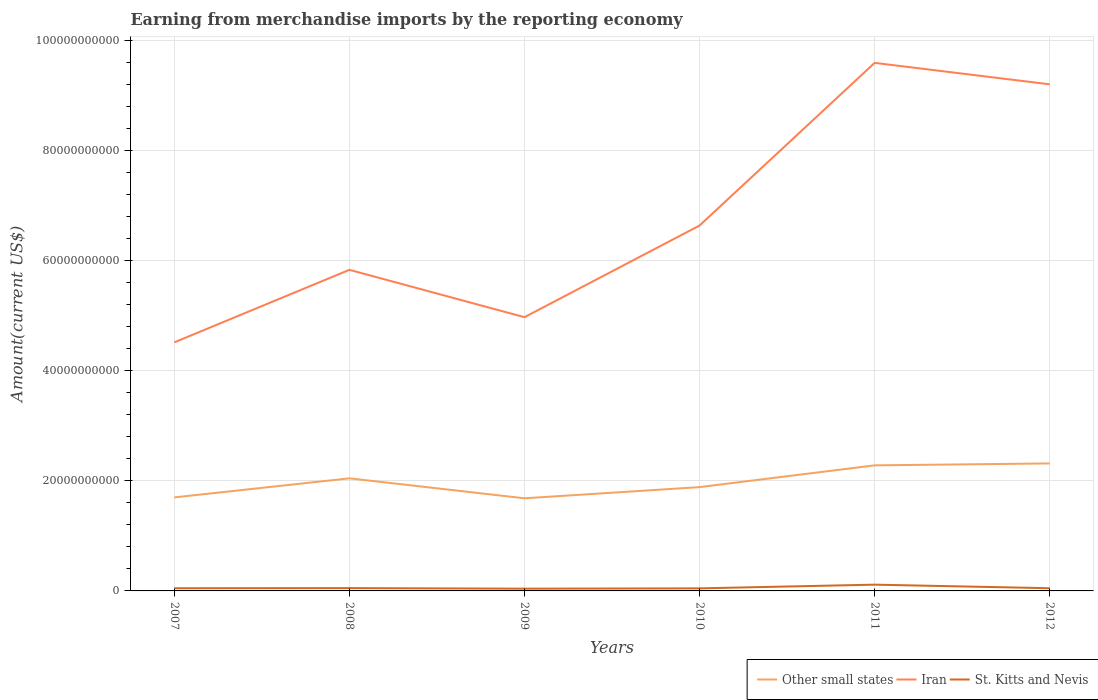How many different coloured lines are there?
Your response must be concise. 3. Is the number of lines equal to the number of legend labels?
Keep it short and to the point. Yes. Across all years, what is the maximum amount earned from merchandise imports in St. Kitts and Nevis?
Give a very brief answer. 4.09e+08. In which year was the amount earned from merchandise imports in St. Kitts and Nevis maximum?
Your answer should be very brief. 2009. What is the total amount earned from merchandise imports in St. Kitts and Nevis in the graph?
Offer a terse response. -2.48e+07. What is the difference between the highest and the second highest amount earned from merchandise imports in St. Kitts and Nevis?
Your answer should be very brief. 7.31e+08. How many lines are there?
Your response must be concise. 3. Are the values on the major ticks of Y-axis written in scientific E-notation?
Your answer should be very brief. No. Does the graph contain any zero values?
Provide a short and direct response. No. Does the graph contain grids?
Keep it short and to the point. Yes. How many legend labels are there?
Provide a succinct answer. 3. How are the legend labels stacked?
Provide a succinct answer. Horizontal. What is the title of the graph?
Provide a short and direct response. Earning from merchandise imports by the reporting economy. Does "Haiti" appear as one of the legend labels in the graph?
Offer a very short reply. No. What is the label or title of the X-axis?
Your answer should be very brief. Years. What is the label or title of the Y-axis?
Ensure brevity in your answer.  Amount(current US$). What is the Amount(current US$) of Other small states in 2007?
Offer a terse response. 1.70e+1. What is the Amount(current US$) in Iran in 2007?
Make the answer very short. 4.52e+1. What is the Amount(current US$) in St. Kitts and Nevis in 2007?
Ensure brevity in your answer.  4.88e+08. What is the Amount(current US$) of Other small states in 2008?
Provide a succinct answer. 2.05e+1. What is the Amount(current US$) in Iran in 2008?
Your response must be concise. 5.83e+1. What is the Amount(current US$) in St. Kitts and Nevis in 2008?
Your answer should be compact. 5.12e+08. What is the Amount(current US$) of Other small states in 2009?
Offer a terse response. 1.68e+1. What is the Amount(current US$) of Iran in 2009?
Offer a terse response. 4.97e+1. What is the Amount(current US$) of St. Kitts and Nevis in 2009?
Your answer should be very brief. 4.09e+08. What is the Amount(current US$) of Other small states in 2010?
Provide a succinct answer. 1.89e+1. What is the Amount(current US$) in Iran in 2010?
Make the answer very short. 6.64e+1. What is the Amount(current US$) in St. Kitts and Nevis in 2010?
Ensure brevity in your answer.  4.66e+08. What is the Amount(current US$) of Other small states in 2011?
Your answer should be very brief. 2.28e+1. What is the Amount(current US$) of Iran in 2011?
Make the answer very short. 9.59e+1. What is the Amount(current US$) in St. Kitts and Nevis in 2011?
Keep it short and to the point. 1.14e+09. What is the Amount(current US$) of Other small states in 2012?
Make the answer very short. 2.32e+1. What is the Amount(current US$) in Iran in 2012?
Ensure brevity in your answer.  9.21e+1. What is the Amount(current US$) of St. Kitts and Nevis in 2012?
Provide a succinct answer. 4.90e+08. Across all years, what is the maximum Amount(current US$) of Other small states?
Your answer should be compact. 2.32e+1. Across all years, what is the maximum Amount(current US$) of Iran?
Make the answer very short. 9.59e+1. Across all years, what is the maximum Amount(current US$) in St. Kitts and Nevis?
Your response must be concise. 1.14e+09. Across all years, what is the minimum Amount(current US$) of Other small states?
Your answer should be compact. 1.68e+1. Across all years, what is the minimum Amount(current US$) of Iran?
Your answer should be very brief. 4.52e+1. Across all years, what is the minimum Amount(current US$) in St. Kitts and Nevis?
Offer a terse response. 4.09e+08. What is the total Amount(current US$) of Other small states in the graph?
Your response must be concise. 1.19e+11. What is the total Amount(current US$) of Iran in the graph?
Give a very brief answer. 4.08e+11. What is the total Amount(current US$) in St. Kitts and Nevis in the graph?
Offer a very short reply. 3.50e+09. What is the difference between the Amount(current US$) in Other small states in 2007 and that in 2008?
Provide a short and direct response. -3.47e+09. What is the difference between the Amount(current US$) of Iran in 2007 and that in 2008?
Ensure brevity in your answer.  -1.32e+1. What is the difference between the Amount(current US$) of St. Kitts and Nevis in 2007 and that in 2008?
Your answer should be very brief. -2.47e+07. What is the difference between the Amount(current US$) in Other small states in 2007 and that in 2009?
Your answer should be very brief. 1.62e+08. What is the difference between the Amount(current US$) in Iran in 2007 and that in 2009?
Ensure brevity in your answer.  -4.57e+09. What is the difference between the Amount(current US$) in St. Kitts and Nevis in 2007 and that in 2009?
Make the answer very short. 7.86e+07. What is the difference between the Amount(current US$) of Other small states in 2007 and that in 2010?
Ensure brevity in your answer.  -1.87e+09. What is the difference between the Amount(current US$) in Iran in 2007 and that in 2010?
Make the answer very short. -2.12e+1. What is the difference between the Amount(current US$) in St. Kitts and Nevis in 2007 and that in 2010?
Give a very brief answer. 2.20e+07. What is the difference between the Amount(current US$) of Other small states in 2007 and that in 2011?
Offer a very short reply. -5.82e+09. What is the difference between the Amount(current US$) in Iran in 2007 and that in 2011?
Your answer should be compact. -5.08e+1. What is the difference between the Amount(current US$) in St. Kitts and Nevis in 2007 and that in 2011?
Offer a terse response. -6.52e+08. What is the difference between the Amount(current US$) in Other small states in 2007 and that in 2012?
Provide a short and direct response. -6.17e+09. What is the difference between the Amount(current US$) of Iran in 2007 and that in 2012?
Give a very brief answer. -4.69e+1. What is the difference between the Amount(current US$) in St. Kitts and Nevis in 2007 and that in 2012?
Offer a very short reply. -2.81e+06. What is the difference between the Amount(current US$) in Other small states in 2008 and that in 2009?
Provide a succinct answer. 3.63e+09. What is the difference between the Amount(current US$) of Iran in 2008 and that in 2009?
Provide a short and direct response. 8.60e+09. What is the difference between the Amount(current US$) in St. Kitts and Nevis in 2008 and that in 2009?
Ensure brevity in your answer.  1.03e+08. What is the difference between the Amount(current US$) of Other small states in 2008 and that in 2010?
Provide a short and direct response. 1.59e+09. What is the difference between the Amount(current US$) in Iran in 2008 and that in 2010?
Keep it short and to the point. -8.05e+09. What is the difference between the Amount(current US$) of St. Kitts and Nevis in 2008 and that in 2010?
Your response must be concise. 4.67e+07. What is the difference between the Amount(current US$) of Other small states in 2008 and that in 2011?
Keep it short and to the point. -2.36e+09. What is the difference between the Amount(current US$) of Iran in 2008 and that in 2011?
Ensure brevity in your answer.  -3.76e+1. What is the difference between the Amount(current US$) of St. Kitts and Nevis in 2008 and that in 2011?
Provide a succinct answer. -6.27e+08. What is the difference between the Amount(current US$) of Other small states in 2008 and that in 2012?
Your answer should be compact. -2.71e+09. What is the difference between the Amount(current US$) in Iran in 2008 and that in 2012?
Your answer should be very brief. -3.37e+1. What is the difference between the Amount(current US$) in St. Kitts and Nevis in 2008 and that in 2012?
Give a very brief answer. 2.19e+07. What is the difference between the Amount(current US$) in Other small states in 2009 and that in 2010?
Your answer should be compact. -2.03e+09. What is the difference between the Amount(current US$) of Iran in 2009 and that in 2010?
Offer a very short reply. -1.67e+1. What is the difference between the Amount(current US$) in St. Kitts and Nevis in 2009 and that in 2010?
Your response must be concise. -5.66e+07. What is the difference between the Amount(current US$) in Other small states in 2009 and that in 2011?
Your response must be concise. -5.98e+09. What is the difference between the Amount(current US$) of Iran in 2009 and that in 2011?
Your response must be concise. -4.62e+1. What is the difference between the Amount(current US$) in St. Kitts and Nevis in 2009 and that in 2011?
Offer a very short reply. -7.31e+08. What is the difference between the Amount(current US$) in Other small states in 2009 and that in 2012?
Your answer should be very brief. -6.34e+09. What is the difference between the Amount(current US$) of Iran in 2009 and that in 2012?
Give a very brief answer. -4.23e+1. What is the difference between the Amount(current US$) of St. Kitts and Nevis in 2009 and that in 2012?
Your answer should be very brief. -8.14e+07. What is the difference between the Amount(current US$) in Other small states in 2010 and that in 2011?
Offer a very short reply. -3.95e+09. What is the difference between the Amount(current US$) of Iran in 2010 and that in 2011?
Provide a succinct answer. -2.96e+1. What is the difference between the Amount(current US$) in St. Kitts and Nevis in 2010 and that in 2011?
Your response must be concise. -6.74e+08. What is the difference between the Amount(current US$) of Other small states in 2010 and that in 2012?
Your response must be concise. -4.30e+09. What is the difference between the Amount(current US$) of Iran in 2010 and that in 2012?
Your response must be concise. -2.57e+1. What is the difference between the Amount(current US$) in St. Kitts and Nevis in 2010 and that in 2012?
Your answer should be very brief. -2.48e+07. What is the difference between the Amount(current US$) of Other small states in 2011 and that in 2012?
Give a very brief answer. -3.52e+08. What is the difference between the Amount(current US$) in Iran in 2011 and that in 2012?
Your answer should be very brief. 3.90e+09. What is the difference between the Amount(current US$) in St. Kitts and Nevis in 2011 and that in 2012?
Offer a terse response. 6.49e+08. What is the difference between the Amount(current US$) of Other small states in 2007 and the Amount(current US$) of Iran in 2008?
Keep it short and to the point. -4.14e+1. What is the difference between the Amount(current US$) of Other small states in 2007 and the Amount(current US$) of St. Kitts and Nevis in 2008?
Make the answer very short. 1.65e+1. What is the difference between the Amount(current US$) in Iran in 2007 and the Amount(current US$) in St. Kitts and Nevis in 2008?
Your answer should be compact. 4.47e+1. What is the difference between the Amount(current US$) of Other small states in 2007 and the Amount(current US$) of Iran in 2009?
Keep it short and to the point. -3.27e+1. What is the difference between the Amount(current US$) in Other small states in 2007 and the Amount(current US$) in St. Kitts and Nevis in 2009?
Provide a succinct answer. 1.66e+1. What is the difference between the Amount(current US$) of Iran in 2007 and the Amount(current US$) of St. Kitts and Nevis in 2009?
Provide a short and direct response. 4.48e+1. What is the difference between the Amount(current US$) of Other small states in 2007 and the Amount(current US$) of Iran in 2010?
Offer a very short reply. -4.94e+1. What is the difference between the Amount(current US$) of Other small states in 2007 and the Amount(current US$) of St. Kitts and Nevis in 2010?
Your response must be concise. 1.65e+1. What is the difference between the Amount(current US$) of Iran in 2007 and the Amount(current US$) of St. Kitts and Nevis in 2010?
Your answer should be compact. 4.47e+1. What is the difference between the Amount(current US$) in Other small states in 2007 and the Amount(current US$) in Iran in 2011?
Provide a short and direct response. -7.90e+1. What is the difference between the Amount(current US$) in Other small states in 2007 and the Amount(current US$) in St. Kitts and Nevis in 2011?
Offer a very short reply. 1.59e+1. What is the difference between the Amount(current US$) of Iran in 2007 and the Amount(current US$) of St. Kitts and Nevis in 2011?
Provide a succinct answer. 4.40e+1. What is the difference between the Amount(current US$) of Other small states in 2007 and the Amount(current US$) of Iran in 2012?
Provide a succinct answer. -7.51e+1. What is the difference between the Amount(current US$) of Other small states in 2007 and the Amount(current US$) of St. Kitts and Nevis in 2012?
Give a very brief answer. 1.65e+1. What is the difference between the Amount(current US$) of Iran in 2007 and the Amount(current US$) of St. Kitts and Nevis in 2012?
Provide a short and direct response. 4.47e+1. What is the difference between the Amount(current US$) of Other small states in 2008 and the Amount(current US$) of Iran in 2009?
Offer a terse response. -2.93e+1. What is the difference between the Amount(current US$) in Other small states in 2008 and the Amount(current US$) in St. Kitts and Nevis in 2009?
Provide a succinct answer. 2.00e+1. What is the difference between the Amount(current US$) of Iran in 2008 and the Amount(current US$) of St. Kitts and Nevis in 2009?
Offer a very short reply. 5.79e+1. What is the difference between the Amount(current US$) of Other small states in 2008 and the Amount(current US$) of Iran in 2010?
Keep it short and to the point. -4.59e+1. What is the difference between the Amount(current US$) of Other small states in 2008 and the Amount(current US$) of St. Kitts and Nevis in 2010?
Offer a very short reply. 2.00e+1. What is the difference between the Amount(current US$) in Iran in 2008 and the Amount(current US$) in St. Kitts and Nevis in 2010?
Give a very brief answer. 5.79e+1. What is the difference between the Amount(current US$) of Other small states in 2008 and the Amount(current US$) of Iran in 2011?
Provide a succinct answer. -7.55e+1. What is the difference between the Amount(current US$) of Other small states in 2008 and the Amount(current US$) of St. Kitts and Nevis in 2011?
Provide a succinct answer. 1.93e+1. What is the difference between the Amount(current US$) in Iran in 2008 and the Amount(current US$) in St. Kitts and Nevis in 2011?
Make the answer very short. 5.72e+1. What is the difference between the Amount(current US$) of Other small states in 2008 and the Amount(current US$) of Iran in 2012?
Your answer should be compact. -7.16e+1. What is the difference between the Amount(current US$) of Other small states in 2008 and the Amount(current US$) of St. Kitts and Nevis in 2012?
Offer a very short reply. 2.00e+1. What is the difference between the Amount(current US$) in Iran in 2008 and the Amount(current US$) in St. Kitts and Nevis in 2012?
Give a very brief answer. 5.79e+1. What is the difference between the Amount(current US$) in Other small states in 2009 and the Amount(current US$) in Iran in 2010?
Your answer should be compact. -4.96e+1. What is the difference between the Amount(current US$) in Other small states in 2009 and the Amount(current US$) in St. Kitts and Nevis in 2010?
Your response must be concise. 1.64e+1. What is the difference between the Amount(current US$) of Iran in 2009 and the Amount(current US$) of St. Kitts and Nevis in 2010?
Keep it short and to the point. 4.93e+1. What is the difference between the Amount(current US$) in Other small states in 2009 and the Amount(current US$) in Iran in 2011?
Your answer should be very brief. -7.91e+1. What is the difference between the Amount(current US$) in Other small states in 2009 and the Amount(current US$) in St. Kitts and Nevis in 2011?
Give a very brief answer. 1.57e+1. What is the difference between the Amount(current US$) in Iran in 2009 and the Amount(current US$) in St. Kitts and Nevis in 2011?
Your answer should be compact. 4.86e+1. What is the difference between the Amount(current US$) in Other small states in 2009 and the Amount(current US$) in Iran in 2012?
Keep it short and to the point. -7.52e+1. What is the difference between the Amount(current US$) in Other small states in 2009 and the Amount(current US$) in St. Kitts and Nevis in 2012?
Give a very brief answer. 1.63e+1. What is the difference between the Amount(current US$) of Iran in 2009 and the Amount(current US$) of St. Kitts and Nevis in 2012?
Keep it short and to the point. 4.93e+1. What is the difference between the Amount(current US$) of Other small states in 2010 and the Amount(current US$) of Iran in 2011?
Your answer should be very brief. -7.71e+1. What is the difference between the Amount(current US$) of Other small states in 2010 and the Amount(current US$) of St. Kitts and Nevis in 2011?
Provide a short and direct response. 1.77e+1. What is the difference between the Amount(current US$) in Iran in 2010 and the Amount(current US$) in St. Kitts and Nevis in 2011?
Your answer should be compact. 6.53e+1. What is the difference between the Amount(current US$) of Other small states in 2010 and the Amount(current US$) of Iran in 2012?
Provide a short and direct response. -7.32e+1. What is the difference between the Amount(current US$) in Other small states in 2010 and the Amount(current US$) in St. Kitts and Nevis in 2012?
Make the answer very short. 1.84e+1. What is the difference between the Amount(current US$) in Iran in 2010 and the Amount(current US$) in St. Kitts and Nevis in 2012?
Your answer should be very brief. 6.59e+1. What is the difference between the Amount(current US$) in Other small states in 2011 and the Amount(current US$) in Iran in 2012?
Ensure brevity in your answer.  -6.92e+1. What is the difference between the Amount(current US$) of Other small states in 2011 and the Amount(current US$) of St. Kitts and Nevis in 2012?
Ensure brevity in your answer.  2.23e+1. What is the difference between the Amount(current US$) in Iran in 2011 and the Amount(current US$) in St. Kitts and Nevis in 2012?
Offer a terse response. 9.55e+1. What is the average Amount(current US$) in Other small states per year?
Provide a short and direct response. 1.99e+1. What is the average Amount(current US$) of Iran per year?
Offer a terse response. 6.79e+1. What is the average Amount(current US$) in St. Kitts and Nevis per year?
Offer a very short reply. 5.84e+08. In the year 2007, what is the difference between the Amount(current US$) of Other small states and Amount(current US$) of Iran?
Ensure brevity in your answer.  -2.82e+1. In the year 2007, what is the difference between the Amount(current US$) in Other small states and Amount(current US$) in St. Kitts and Nevis?
Give a very brief answer. 1.65e+1. In the year 2007, what is the difference between the Amount(current US$) in Iran and Amount(current US$) in St. Kitts and Nevis?
Give a very brief answer. 4.47e+1. In the year 2008, what is the difference between the Amount(current US$) in Other small states and Amount(current US$) in Iran?
Keep it short and to the point. -3.79e+1. In the year 2008, what is the difference between the Amount(current US$) of Other small states and Amount(current US$) of St. Kitts and Nevis?
Offer a very short reply. 1.99e+1. In the year 2008, what is the difference between the Amount(current US$) of Iran and Amount(current US$) of St. Kitts and Nevis?
Your answer should be very brief. 5.78e+1. In the year 2009, what is the difference between the Amount(current US$) in Other small states and Amount(current US$) in Iran?
Provide a succinct answer. -3.29e+1. In the year 2009, what is the difference between the Amount(current US$) in Other small states and Amount(current US$) in St. Kitts and Nevis?
Provide a succinct answer. 1.64e+1. In the year 2009, what is the difference between the Amount(current US$) of Iran and Amount(current US$) of St. Kitts and Nevis?
Make the answer very short. 4.93e+1. In the year 2010, what is the difference between the Amount(current US$) of Other small states and Amount(current US$) of Iran?
Give a very brief answer. -4.75e+1. In the year 2010, what is the difference between the Amount(current US$) in Other small states and Amount(current US$) in St. Kitts and Nevis?
Offer a very short reply. 1.84e+1. In the year 2010, what is the difference between the Amount(current US$) in Iran and Amount(current US$) in St. Kitts and Nevis?
Provide a short and direct response. 6.59e+1. In the year 2011, what is the difference between the Amount(current US$) of Other small states and Amount(current US$) of Iran?
Give a very brief answer. -7.31e+1. In the year 2011, what is the difference between the Amount(current US$) of Other small states and Amount(current US$) of St. Kitts and Nevis?
Provide a short and direct response. 2.17e+1. In the year 2011, what is the difference between the Amount(current US$) of Iran and Amount(current US$) of St. Kitts and Nevis?
Offer a very short reply. 9.48e+1. In the year 2012, what is the difference between the Amount(current US$) in Other small states and Amount(current US$) in Iran?
Give a very brief answer. -6.89e+1. In the year 2012, what is the difference between the Amount(current US$) of Other small states and Amount(current US$) of St. Kitts and Nevis?
Provide a short and direct response. 2.27e+1. In the year 2012, what is the difference between the Amount(current US$) of Iran and Amount(current US$) of St. Kitts and Nevis?
Your response must be concise. 9.16e+1. What is the ratio of the Amount(current US$) of Other small states in 2007 to that in 2008?
Offer a very short reply. 0.83. What is the ratio of the Amount(current US$) of Iran in 2007 to that in 2008?
Your response must be concise. 0.77. What is the ratio of the Amount(current US$) in St. Kitts and Nevis in 2007 to that in 2008?
Give a very brief answer. 0.95. What is the ratio of the Amount(current US$) in Other small states in 2007 to that in 2009?
Provide a short and direct response. 1.01. What is the ratio of the Amount(current US$) of Iran in 2007 to that in 2009?
Your answer should be compact. 0.91. What is the ratio of the Amount(current US$) of St. Kitts and Nevis in 2007 to that in 2009?
Offer a terse response. 1.19. What is the ratio of the Amount(current US$) of Other small states in 2007 to that in 2010?
Ensure brevity in your answer.  0.9. What is the ratio of the Amount(current US$) in Iran in 2007 to that in 2010?
Provide a succinct answer. 0.68. What is the ratio of the Amount(current US$) in St. Kitts and Nevis in 2007 to that in 2010?
Your response must be concise. 1.05. What is the ratio of the Amount(current US$) of Other small states in 2007 to that in 2011?
Provide a succinct answer. 0.74. What is the ratio of the Amount(current US$) of Iran in 2007 to that in 2011?
Keep it short and to the point. 0.47. What is the ratio of the Amount(current US$) in St. Kitts and Nevis in 2007 to that in 2011?
Offer a very short reply. 0.43. What is the ratio of the Amount(current US$) in Other small states in 2007 to that in 2012?
Your answer should be very brief. 0.73. What is the ratio of the Amount(current US$) of Iran in 2007 to that in 2012?
Provide a succinct answer. 0.49. What is the ratio of the Amount(current US$) in Other small states in 2008 to that in 2009?
Give a very brief answer. 1.22. What is the ratio of the Amount(current US$) in Iran in 2008 to that in 2009?
Offer a very short reply. 1.17. What is the ratio of the Amount(current US$) in St. Kitts and Nevis in 2008 to that in 2009?
Your response must be concise. 1.25. What is the ratio of the Amount(current US$) in Other small states in 2008 to that in 2010?
Keep it short and to the point. 1.08. What is the ratio of the Amount(current US$) in Iran in 2008 to that in 2010?
Give a very brief answer. 0.88. What is the ratio of the Amount(current US$) in St. Kitts and Nevis in 2008 to that in 2010?
Provide a short and direct response. 1.1. What is the ratio of the Amount(current US$) of Other small states in 2008 to that in 2011?
Your answer should be compact. 0.9. What is the ratio of the Amount(current US$) of Iran in 2008 to that in 2011?
Keep it short and to the point. 0.61. What is the ratio of the Amount(current US$) in St. Kitts and Nevis in 2008 to that in 2011?
Provide a succinct answer. 0.45. What is the ratio of the Amount(current US$) of Other small states in 2008 to that in 2012?
Give a very brief answer. 0.88. What is the ratio of the Amount(current US$) of Iran in 2008 to that in 2012?
Your answer should be compact. 0.63. What is the ratio of the Amount(current US$) in St. Kitts and Nevis in 2008 to that in 2012?
Your answer should be compact. 1.04. What is the ratio of the Amount(current US$) of Other small states in 2009 to that in 2010?
Offer a terse response. 0.89. What is the ratio of the Amount(current US$) of Iran in 2009 to that in 2010?
Provide a succinct answer. 0.75. What is the ratio of the Amount(current US$) in St. Kitts and Nevis in 2009 to that in 2010?
Your response must be concise. 0.88. What is the ratio of the Amount(current US$) of Other small states in 2009 to that in 2011?
Provide a short and direct response. 0.74. What is the ratio of the Amount(current US$) of Iran in 2009 to that in 2011?
Give a very brief answer. 0.52. What is the ratio of the Amount(current US$) in St. Kitts and Nevis in 2009 to that in 2011?
Offer a terse response. 0.36. What is the ratio of the Amount(current US$) of Other small states in 2009 to that in 2012?
Your answer should be compact. 0.73. What is the ratio of the Amount(current US$) of Iran in 2009 to that in 2012?
Your response must be concise. 0.54. What is the ratio of the Amount(current US$) in St. Kitts and Nevis in 2009 to that in 2012?
Provide a succinct answer. 0.83. What is the ratio of the Amount(current US$) in Other small states in 2010 to that in 2011?
Your answer should be very brief. 0.83. What is the ratio of the Amount(current US$) of Iran in 2010 to that in 2011?
Ensure brevity in your answer.  0.69. What is the ratio of the Amount(current US$) in St. Kitts and Nevis in 2010 to that in 2011?
Offer a terse response. 0.41. What is the ratio of the Amount(current US$) of Other small states in 2010 to that in 2012?
Offer a very short reply. 0.81. What is the ratio of the Amount(current US$) of Iran in 2010 to that in 2012?
Your answer should be compact. 0.72. What is the ratio of the Amount(current US$) in St. Kitts and Nevis in 2010 to that in 2012?
Your answer should be compact. 0.95. What is the ratio of the Amount(current US$) in Other small states in 2011 to that in 2012?
Keep it short and to the point. 0.98. What is the ratio of the Amount(current US$) of Iran in 2011 to that in 2012?
Offer a very short reply. 1.04. What is the ratio of the Amount(current US$) of St. Kitts and Nevis in 2011 to that in 2012?
Offer a very short reply. 2.32. What is the difference between the highest and the second highest Amount(current US$) of Other small states?
Ensure brevity in your answer.  3.52e+08. What is the difference between the highest and the second highest Amount(current US$) in Iran?
Provide a succinct answer. 3.90e+09. What is the difference between the highest and the second highest Amount(current US$) of St. Kitts and Nevis?
Make the answer very short. 6.27e+08. What is the difference between the highest and the lowest Amount(current US$) in Other small states?
Provide a succinct answer. 6.34e+09. What is the difference between the highest and the lowest Amount(current US$) in Iran?
Your answer should be very brief. 5.08e+1. What is the difference between the highest and the lowest Amount(current US$) in St. Kitts and Nevis?
Make the answer very short. 7.31e+08. 